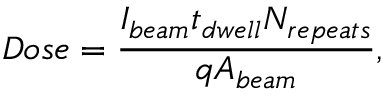Convert formula to latex. <formula><loc_0><loc_0><loc_500><loc_500>D o s e = \frac { I _ { b e a m } t _ { d w e l l } N _ { r e p e a t s } } { q A _ { b e a m } } ,</formula> 